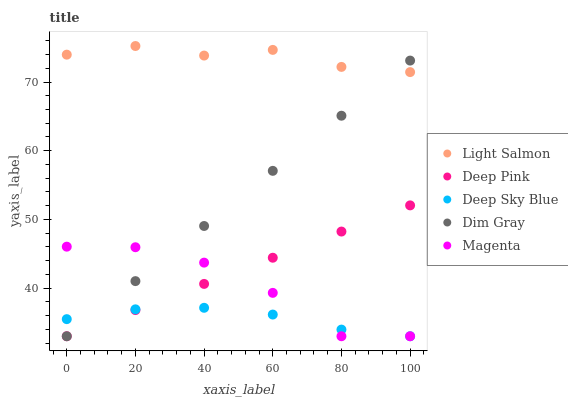Does Deep Sky Blue have the minimum area under the curve?
Answer yes or no. Yes. Does Light Salmon have the maximum area under the curve?
Answer yes or no. Yes. Does Deep Pink have the minimum area under the curve?
Answer yes or no. No. Does Deep Pink have the maximum area under the curve?
Answer yes or no. No. Is Deep Pink the smoothest?
Answer yes or no. Yes. Is Magenta the roughest?
Answer yes or no. Yes. Is Light Salmon the smoothest?
Answer yes or no. No. Is Light Salmon the roughest?
Answer yes or no. No. Does Dim Gray have the lowest value?
Answer yes or no. Yes. Does Light Salmon have the lowest value?
Answer yes or no. No. Does Light Salmon have the highest value?
Answer yes or no. Yes. Does Deep Pink have the highest value?
Answer yes or no. No. Is Deep Pink less than Light Salmon?
Answer yes or no. Yes. Is Light Salmon greater than Deep Sky Blue?
Answer yes or no. Yes. Does Deep Sky Blue intersect Dim Gray?
Answer yes or no. Yes. Is Deep Sky Blue less than Dim Gray?
Answer yes or no. No. Is Deep Sky Blue greater than Dim Gray?
Answer yes or no. No. Does Deep Pink intersect Light Salmon?
Answer yes or no. No. 